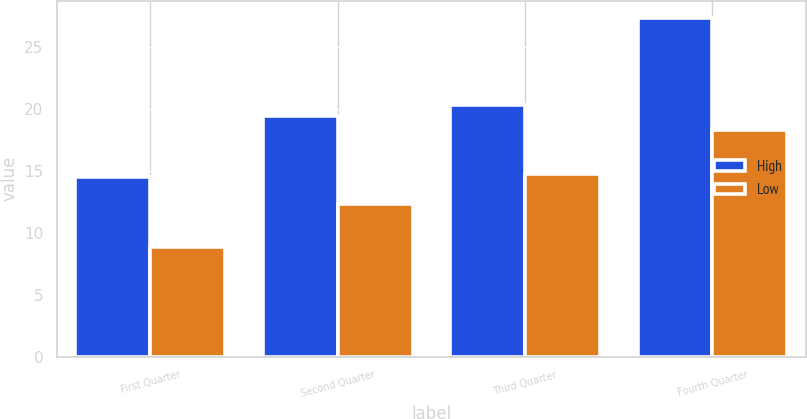<chart> <loc_0><loc_0><loc_500><loc_500><stacked_bar_chart><ecel><fcel>First Quarter<fcel>Second Quarter<fcel>Third Quarter<fcel>Fourth Quarter<nl><fcel>High<fcel>14.5<fcel>19.42<fcel>20.36<fcel>27.4<nl><fcel>Low<fcel>8.89<fcel>12.31<fcel>14.77<fcel>18.34<nl></chart> 